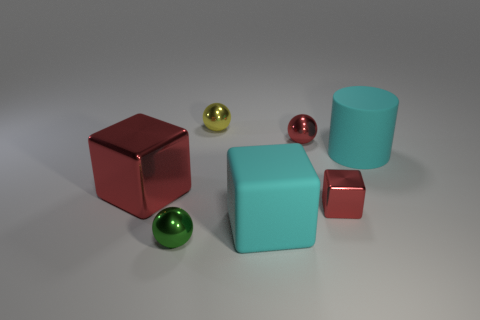There is a tiny green thing; is it the same shape as the tiny red object that is in front of the cyan rubber cylinder?
Offer a terse response. No. What number of tiny things are cylinders or purple things?
Your answer should be very brief. 0. Are there any blue metal balls of the same size as the cyan block?
Make the answer very short. No. What is the color of the shiny ball that is in front of the big cylinder behind the big cyan rubber object in front of the large red object?
Ensure brevity in your answer.  Green. Is the tiny yellow sphere made of the same material as the tiny object that is on the left side of the small yellow shiny object?
Provide a succinct answer. Yes. What size is the cyan matte thing that is the same shape as the big red metal thing?
Ensure brevity in your answer.  Large. Are there an equal number of large cyan blocks that are to the left of the small yellow sphere and red things in front of the big red cube?
Your answer should be compact. No. How many other objects are the same material as the large red cube?
Make the answer very short. 4. Is the number of metallic things that are in front of the cyan block the same as the number of cyan objects?
Keep it short and to the point. No. Do the rubber cube and the metallic block on the left side of the red ball have the same size?
Keep it short and to the point. Yes. 